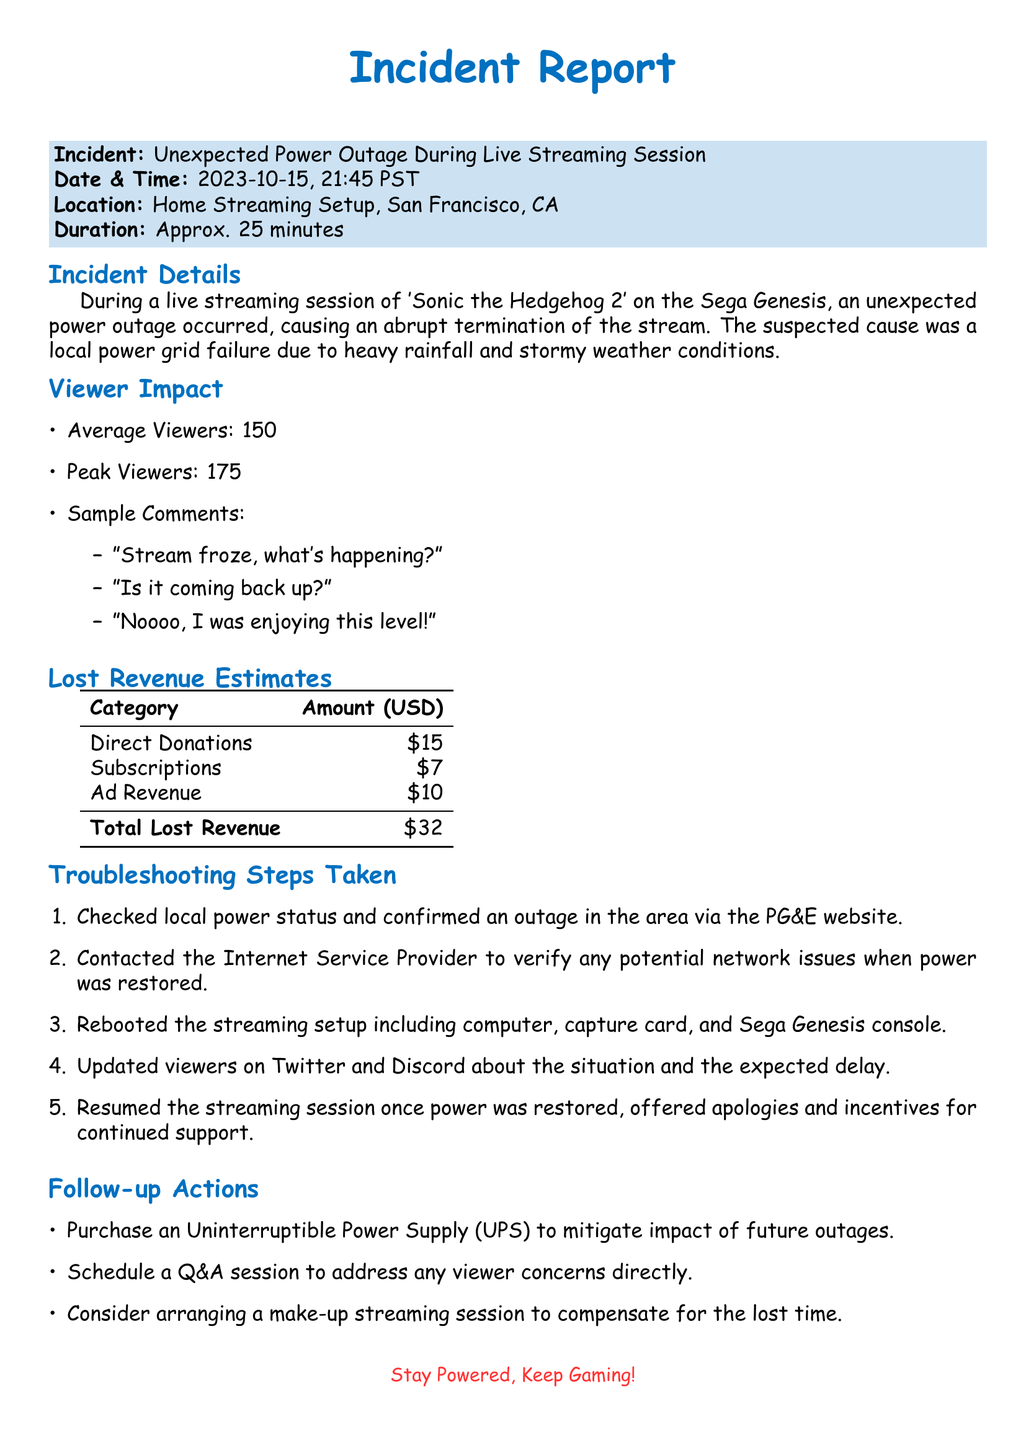what was the incident during the streaming session? The incident was an unexpected power outage during the live streaming session.
Answer: Unexpected power outage what was the date and time of the incident? The date and time are specified in the document as when the incident occurred.
Answer: 2023-10-15, 21:45 PST how long did the power outage last? The duration of the power outage is noted in the incident report.
Answer: Approx. 25 minutes what was the total lost revenue from the incident? The total lost revenue is calculated by summing the amounts from different categories listed in the document.
Answer: $32 what were the average viewers during the streaming session? The average viewers are mentioned in the viewer impact section of the report.
Answer: 150 what is one of the troubleshooting steps taken after the outage? Troubleshooting steps require reasoning about the actions taken post-incident.
Answer: Checked local power status what is the purpose of the follow-up actions listed in the report? The follow-up actions are intended to address the consequences of the outage and improve future streaming sessions.
Answer: Mitigate impact of future outages where did the incident occur? The location of the incident is specified within the document.
Answer: Home Streaming Setup, San Francisco, CA what feedback did viewers provide during the outage? Sample comments from viewers reflect their reactions during the incident.
Answer: "Stream froze, what's happening?" 